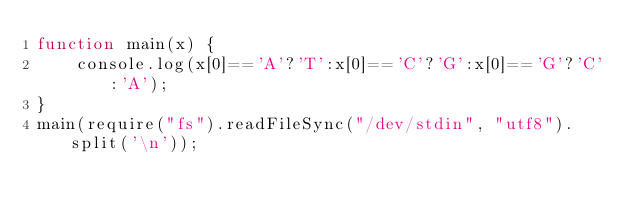Convert code to text. <code><loc_0><loc_0><loc_500><loc_500><_JavaScript_>function main(x) {
    console.log(x[0]=='A'?'T':x[0]=='C'?'G':x[0]=='G'?'C':'A');
}
main(require("fs").readFileSync("/dev/stdin", "utf8").split('\n'));</code> 